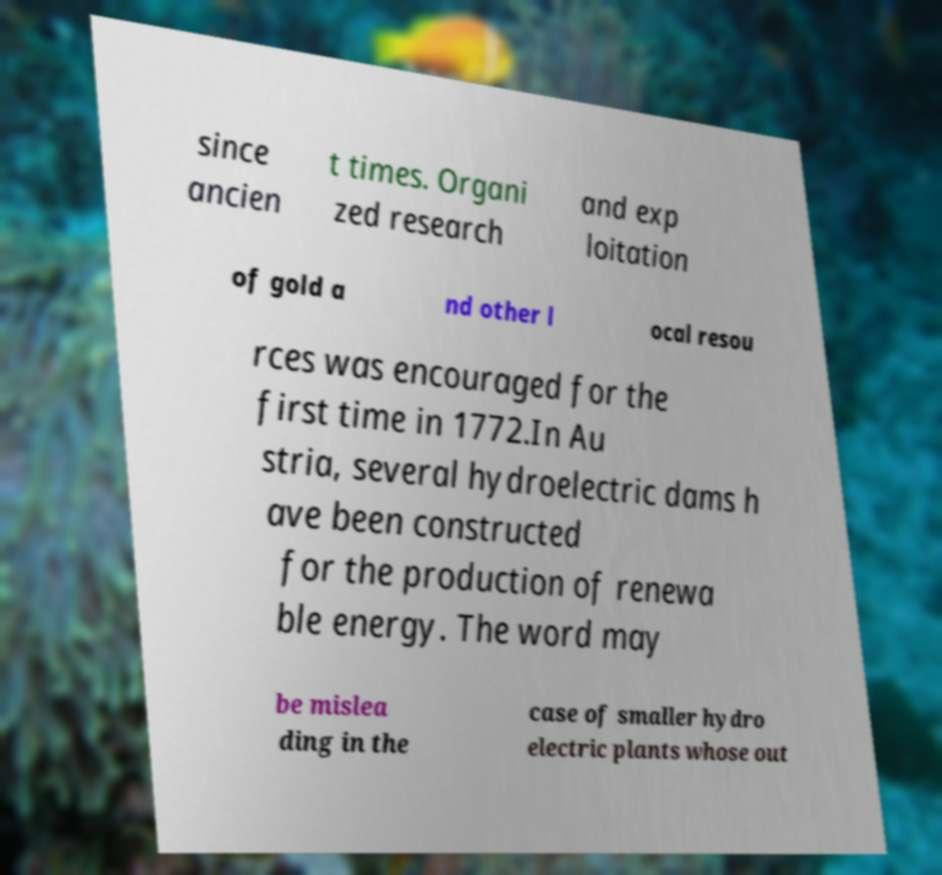For documentation purposes, I need the text within this image transcribed. Could you provide that? since ancien t times. Organi zed research and exp loitation of gold a nd other l ocal resou rces was encouraged for the first time in 1772.In Au stria, several hydroelectric dams h ave been constructed for the production of renewa ble energy. The word may be mislea ding in the case of smaller hydro electric plants whose out 